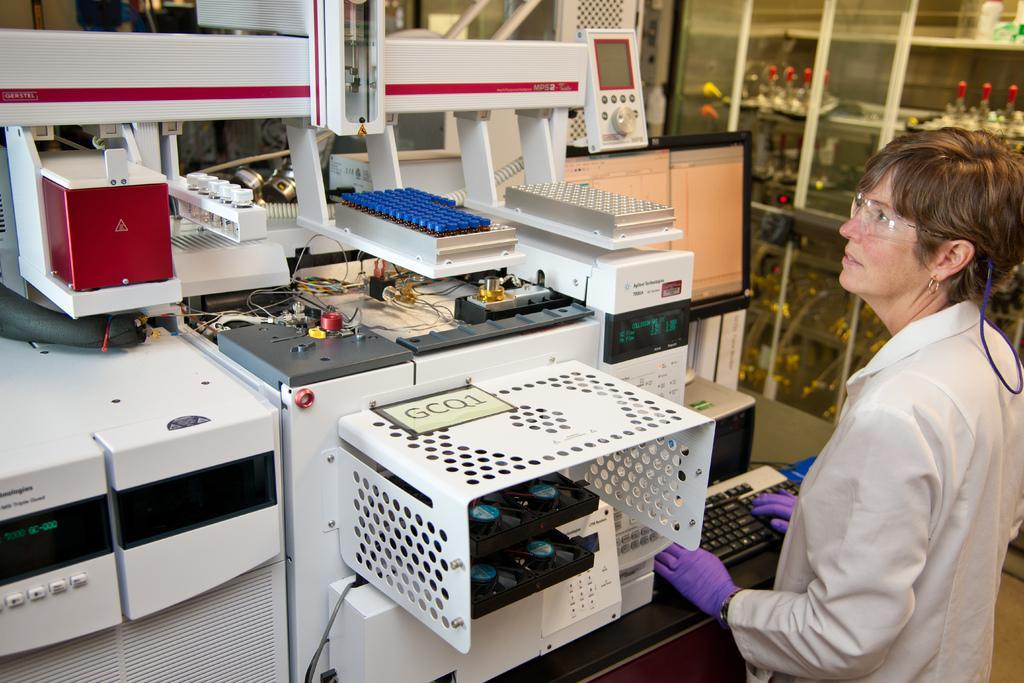In one or two sentences, can you explain what this image depicts? On the right side of the image we can see a lady standing. She is wearing an apron we can see a keyboard and there are machines. On the right there is a door. 